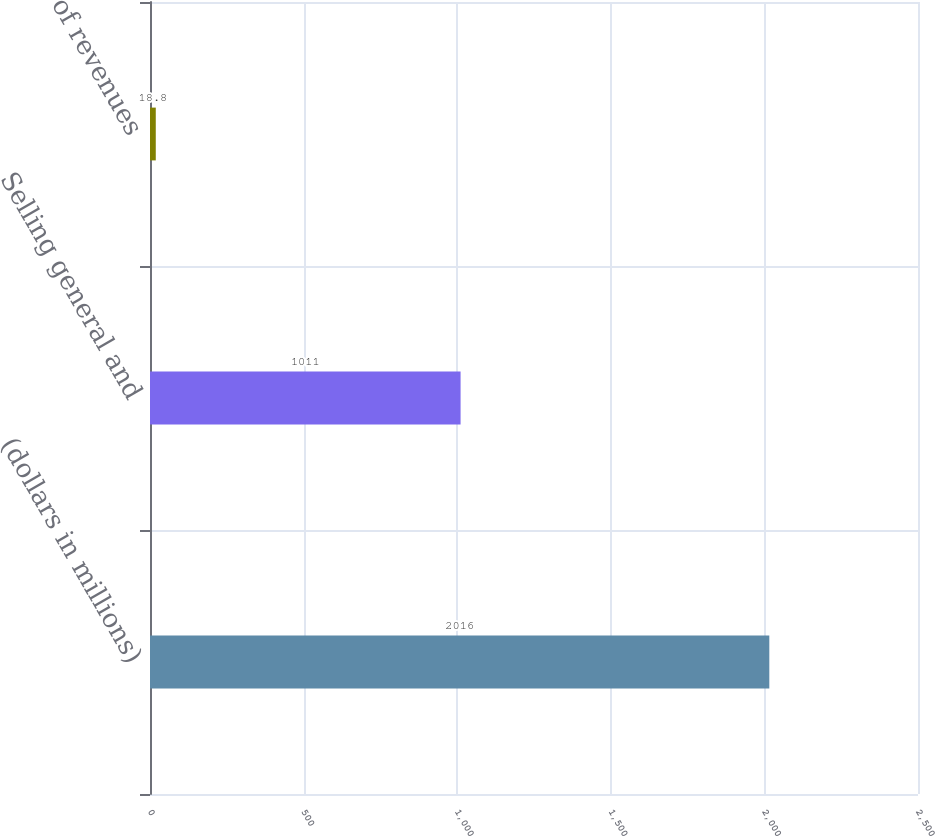Convert chart. <chart><loc_0><loc_0><loc_500><loc_500><bar_chart><fcel>(dollars in millions)<fcel>Selling general and<fcel>of revenues<nl><fcel>2016<fcel>1011<fcel>18.8<nl></chart> 